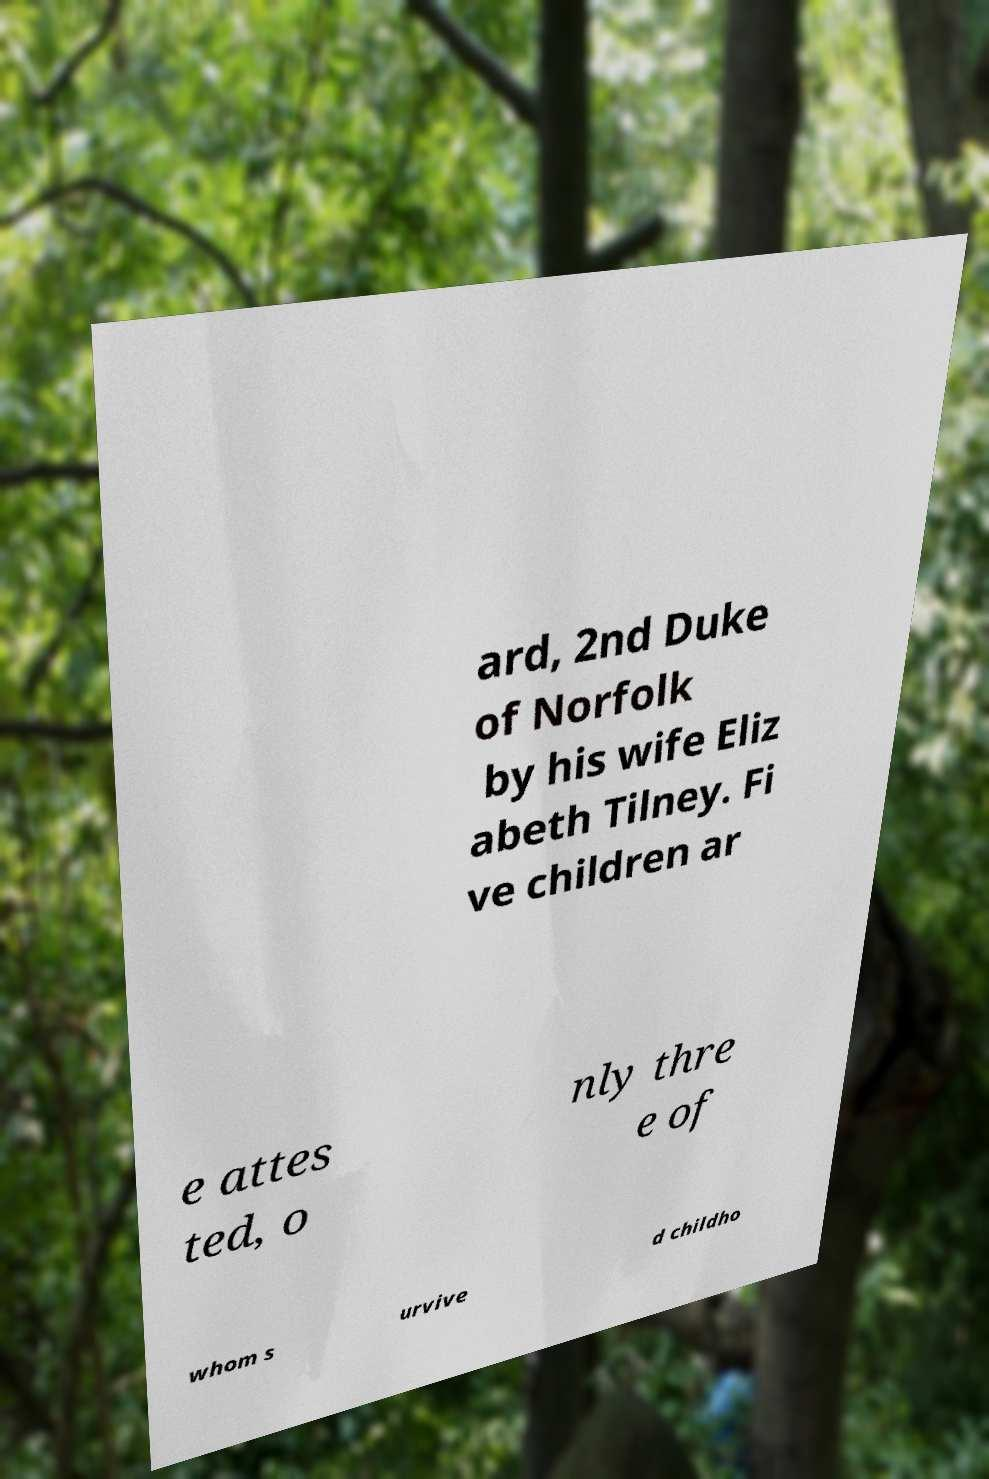Please identify and transcribe the text found in this image. ard, 2nd Duke of Norfolk by his wife Eliz abeth Tilney. Fi ve children ar e attes ted, o nly thre e of whom s urvive d childho 